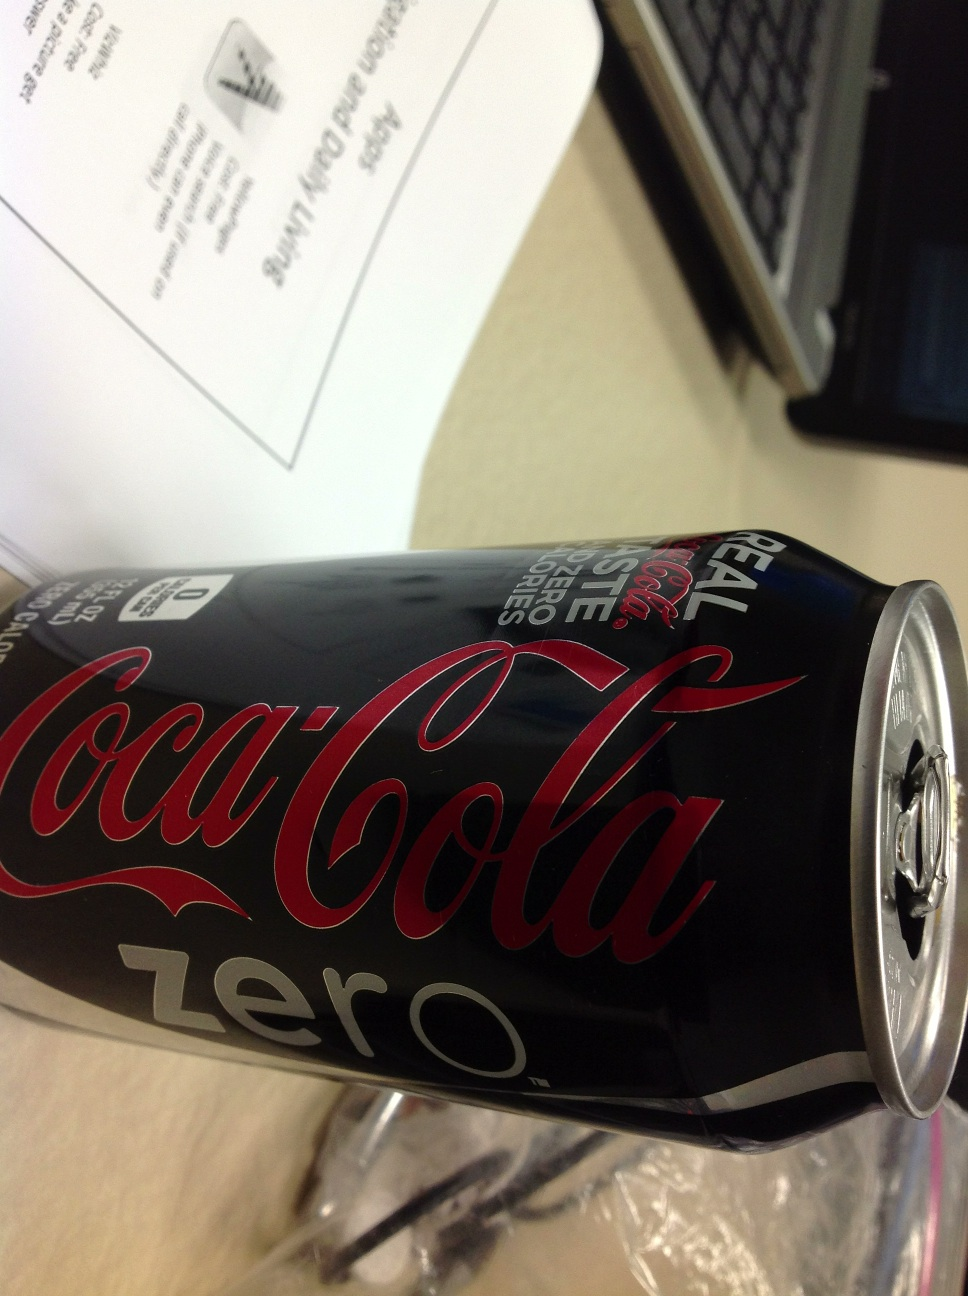What is it? This is a can of Coca-Cola Zero, commonly known as Coke Zero, which is a zero-calorie variation of the classic Coca-Cola beverage, prominently displaying its logo and design in a rotated view. 